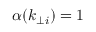Convert formula to latex. <formula><loc_0><loc_0><loc_500><loc_500>\alpha ( k _ { \perp i } ) = 1</formula> 